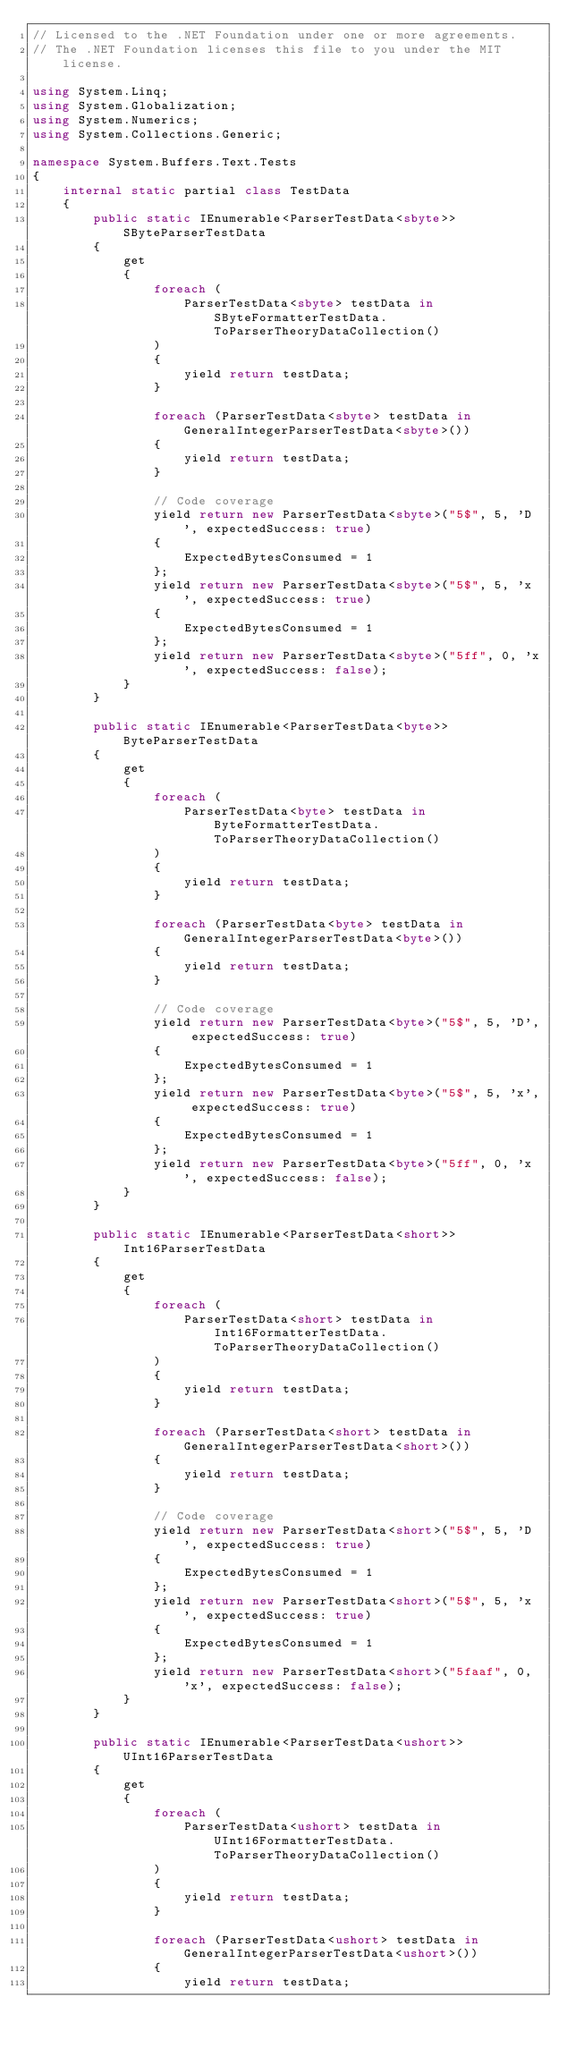Convert code to text. <code><loc_0><loc_0><loc_500><loc_500><_C#_>// Licensed to the .NET Foundation under one or more agreements.
// The .NET Foundation licenses this file to you under the MIT license.

using System.Linq;
using System.Globalization;
using System.Numerics;
using System.Collections.Generic;

namespace System.Buffers.Text.Tests
{
    internal static partial class TestData
    {
        public static IEnumerable<ParserTestData<sbyte>> SByteParserTestData
        {
            get
            {
                foreach (
                    ParserTestData<sbyte> testData in SByteFormatterTestData.ToParserTheoryDataCollection()
                )
                {
                    yield return testData;
                }

                foreach (ParserTestData<sbyte> testData in GeneralIntegerParserTestData<sbyte>())
                {
                    yield return testData;
                }

                // Code coverage
                yield return new ParserTestData<sbyte>("5$", 5, 'D', expectedSuccess: true)
                {
                    ExpectedBytesConsumed = 1
                };
                yield return new ParserTestData<sbyte>("5$", 5, 'x', expectedSuccess: true)
                {
                    ExpectedBytesConsumed = 1
                };
                yield return new ParserTestData<sbyte>("5ff", 0, 'x', expectedSuccess: false);
            }
        }

        public static IEnumerable<ParserTestData<byte>> ByteParserTestData
        {
            get
            {
                foreach (
                    ParserTestData<byte> testData in ByteFormatterTestData.ToParserTheoryDataCollection()
                )
                {
                    yield return testData;
                }

                foreach (ParserTestData<byte> testData in GeneralIntegerParserTestData<byte>())
                {
                    yield return testData;
                }

                // Code coverage
                yield return new ParserTestData<byte>("5$", 5, 'D', expectedSuccess: true)
                {
                    ExpectedBytesConsumed = 1
                };
                yield return new ParserTestData<byte>("5$", 5, 'x', expectedSuccess: true)
                {
                    ExpectedBytesConsumed = 1
                };
                yield return new ParserTestData<byte>("5ff", 0, 'x', expectedSuccess: false);
            }
        }

        public static IEnumerable<ParserTestData<short>> Int16ParserTestData
        {
            get
            {
                foreach (
                    ParserTestData<short> testData in Int16FormatterTestData.ToParserTheoryDataCollection()
                )
                {
                    yield return testData;
                }

                foreach (ParserTestData<short> testData in GeneralIntegerParserTestData<short>())
                {
                    yield return testData;
                }

                // Code coverage
                yield return new ParserTestData<short>("5$", 5, 'D', expectedSuccess: true)
                {
                    ExpectedBytesConsumed = 1
                };
                yield return new ParserTestData<short>("5$", 5, 'x', expectedSuccess: true)
                {
                    ExpectedBytesConsumed = 1
                };
                yield return new ParserTestData<short>("5faaf", 0, 'x', expectedSuccess: false);
            }
        }

        public static IEnumerable<ParserTestData<ushort>> UInt16ParserTestData
        {
            get
            {
                foreach (
                    ParserTestData<ushort> testData in UInt16FormatterTestData.ToParserTheoryDataCollection()
                )
                {
                    yield return testData;
                }

                foreach (ParserTestData<ushort> testData in GeneralIntegerParserTestData<ushort>())
                {
                    yield return testData;</code> 